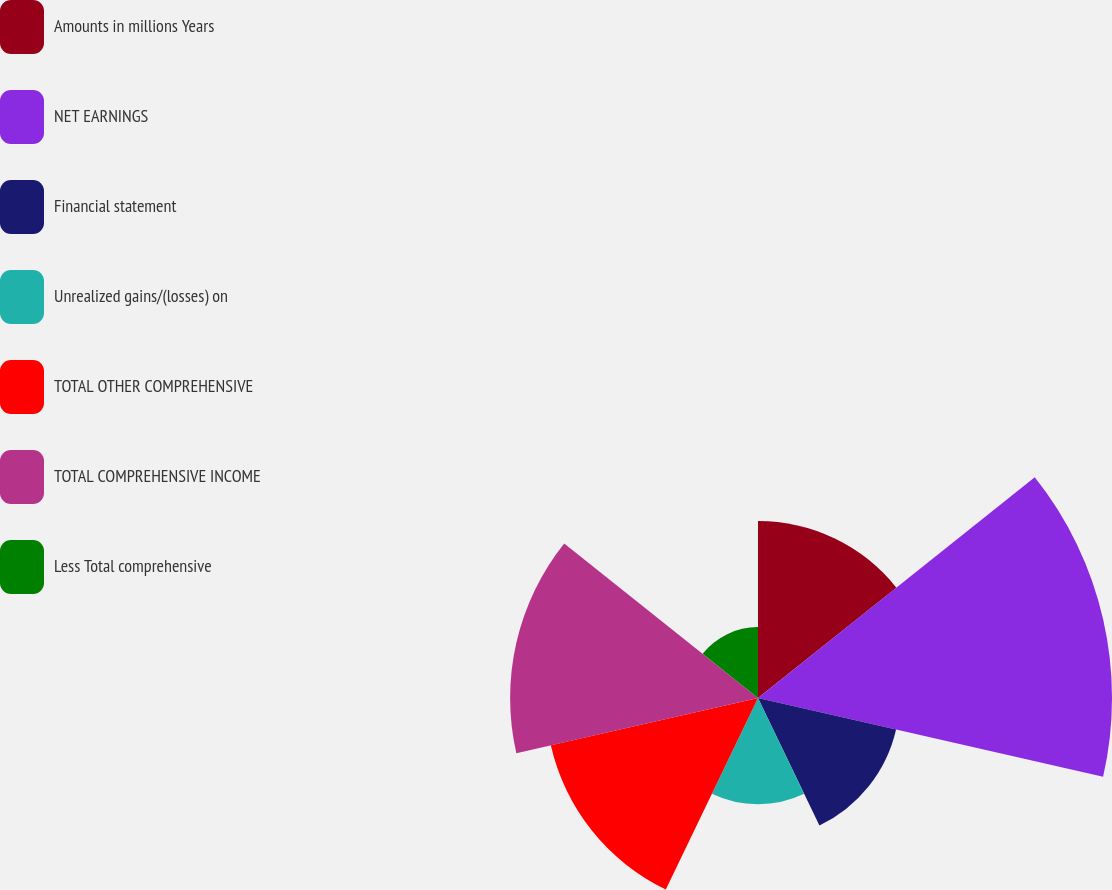Convert chart to OTSL. <chart><loc_0><loc_0><loc_500><loc_500><pie_chart><fcel>Amounts in millions Years<fcel>NET EARNINGS<fcel>Financial statement<fcel>Unrealized gains/(losses) on<fcel>TOTAL OTHER COMPREHENSIVE<fcel>TOTAL COMPREHENSIVE INCOME<fcel>Less Total comprehensive<nl><fcel>13.51%<fcel>27.02%<fcel>10.81%<fcel>8.11%<fcel>16.22%<fcel>18.92%<fcel>5.41%<nl></chart> 